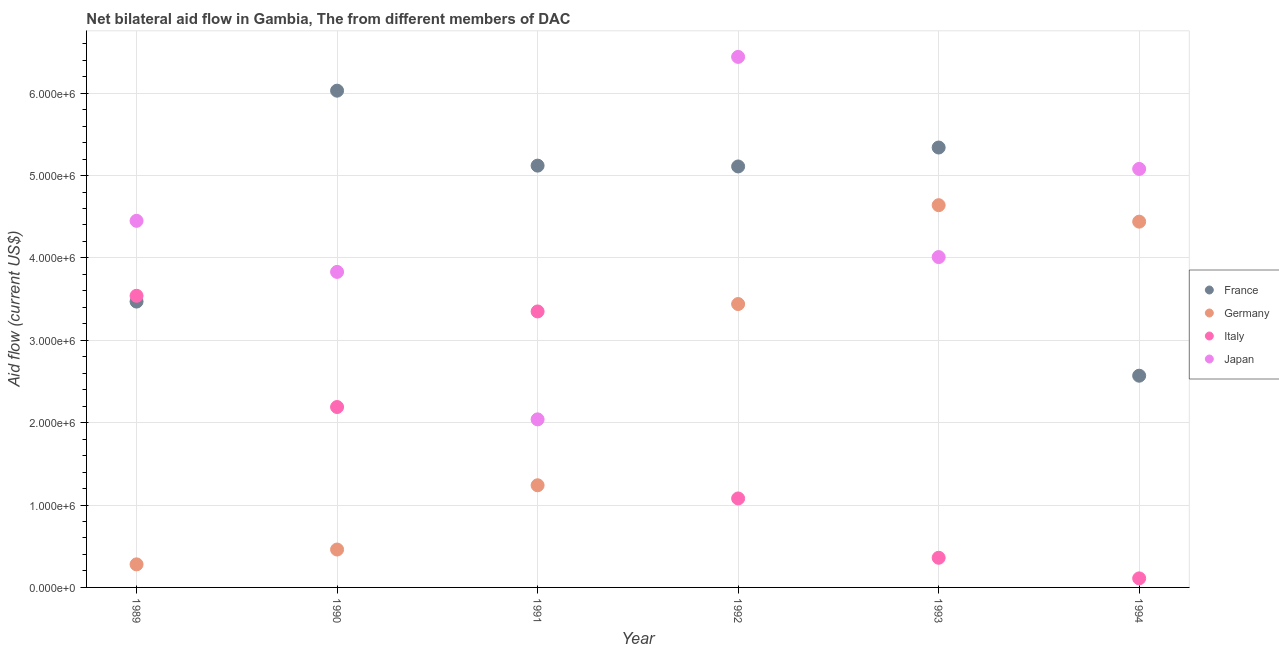Is the number of dotlines equal to the number of legend labels?
Ensure brevity in your answer.  Yes. What is the amount of aid given by italy in 1989?
Make the answer very short. 3.54e+06. Across all years, what is the maximum amount of aid given by france?
Ensure brevity in your answer.  6.03e+06. Across all years, what is the minimum amount of aid given by france?
Offer a terse response. 2.57e+06. What is the total amount of aid given by germany in the graph?
Provide a short and direct response. 1.45e+07. What is the difference between the amount of aid given by italy in 1989 and that in 1993?
Give a very brief answer. 3.18e+06. What is the difference between the amount of aid given by france in 1989 and the amount of aid given by japan in 1994?
Provide a short and direct response. -1.61e+06. What is the average amount of aid given by japan per year?
Your answer should be compact. 4.31e+06. In the year 1989, what is the difference between the amount of aid given by italy and amount of aid given by japan?
Give a very brief answer. -9.10e+05. What is the ratio of the amount of aid given by japan in 1991 to that in 1994?
Your answer should be compact. 0.4. Is the amount of aid given by italy in 1989 less than that in 1994?
Ensure brevity in your answer.  No. Is the difference between the amount of aid given by france in 1990 and 1994 greater than the difference between the amount of aid given by japan in 1990 and 1994?
Your answer should be compact. Yes. What is the difference between the highest and the second highest amount of aid given by germany?
Give a very brief answer. 2.00e+05. What is the difference between the highest and the lowest amount of aid given by germany?
Give a very brief answer. 4.36e+06. Is the sum of the amount of aid given by france in 1990 and 1991 greater than the maximum amount of aid given by italy across all years?
Ensure brevity in your answer.  Yes. Is it the case that in every year, the sum of the amount of aid given by france and amount of aid given by italy is greater than the sum of amount of aid given by germany and amount of aid given by japan?
Keep it short and to the point. No. Is it the case that in every year, the sum of the amount of aid given by france and amount of aid given by germany is greater than the amount of aid given by italy?
Your answer should be very brief. Yes. Does the amount of aid given by japan monotonically increase over the years?
Keep it short and to the point. No. Is the amount of aid given by germany strictly less than the amount of aid given by japan over the years?
Your response must be concise. No. How many dotlines are there?
Your response must be concise. 4. Does the graph contain grids?
Offer a very short reply. Yes. Where does the legend appear in the graph?
Offer a very short reply. Center right. How many legend labels are there?
Your answer should be very brief. 4. What is the title of the graph?
Your response must be concise. Net bilateral aid flow in Gambia, The from different members of DAC. Does "Burnt food" appear as one of the legend labels in the graph?
Give a very brief answer. No. What is the Aid flow (current US$) in France in 1989?
Make the answer very short. 3.47e+06. What is the Aid flow (current US$) of Italy in 1989?
Provide a succinct answer. 3.54e+06. What is the Aid flow (current US$) of Japan in 1989?
Your answer should be very brief. 4.45e+06. What is the Aid flow (current US$) of France in 1990?
Give a very brief answer. 6.03e+06. What is the Aid flow (current US$) in Italy in 1990?
Your answer should be compact. 2.19e+06. What is the Aid flow (current US$) of Japan in 1990?
Make the answer very short. 3.83e+06. What is the Aid flow (current US$) of France in 1991?
Your answer should be compact. 5.12e+06. What is the Aid flow (current US$) of Germany in 1991?
Your answer should be compact. 1.24e+06. What is the Aid flow (current US$) of Italy in 1991?
Give a very brief answer. 3.35e+06. What is the Aid flow (current US$) of Japan in 1991?
Offer a terse response. 2.04e+06. What is the Aid flow (current US$) of France in 1992?
Make the answer very short. 5.11e+06. What is the Aid flow (current US$) in Germany in 1992?
Offer a very short reply. 3.44e+06. What is the Aid flow (current US$) in Italy in 1992?
Your response must be concise. 1.08e+06. What is the Aid flow (current US$) of Japan in 1992?
Keep it short and to the point. 6.44e+06. What is the Aid flow (current US$) of France in 1993?
Offer a very short reply. 5.34e+06. What is the Aid flow (current US$) of Germany in 1993?
Your response must be concise. 4.64e+06. What is the Aid flow (current US$) of Japan in 1993?
Provide a short and direct response. 4.01e+06. What is the Aid flow (current US$) of France in 1994?
Give a very brief answer. 2.57e+06. What is the Aid flow (current US$) in Germany in 1994?
Keep it short and to the point. 4.44e+06. What is the Aid flow (current US$) of Japan in 1994?
Make the answer very short. 5.08e+06. Across all years, what is the maximum Aid flow (current US$) of France?
Keep it short and to the point. 6.03e+06. Across all years, what is the maximum Aid flow (current US$) in Germany?
Your answer should be compact. 4.64e+06. Across all years, what is the maximum Aid flow (current US$) in Italy?
Offer a terse response. 3.54e+06. Across all years, what is the maximum Aid flow (current US$) in Japan?
Your answer should be compact. 6.44e+06. Across all years, what is the minimum Aid flow (current US$) in France?
Your answer should be very brief. 2.57e+06. Across all years, what is the minimum Aid flow (current US$) in Japan?
Keep it short and to the point. 2.04e+06. What is the total Aid flow (current US$) of France in the graph?
Ensure brevity in your answer.  2.76e+07. What is the total Aid flow (current US$) in Germany in the graph?
Provide a succinct answer. 1.45e+07. What is the total Aid flow (current US$) of Italy in the graph?
Offer a terse response. 1.06e+07. What is the total Aid flow (current US$) of Japan in the graph?
Offer a terse response. 2.58e+07. What is the difference between the Aid flow (current US$) of France in 1989 and that in 1990?
Your response must be concise. -2.56e+06. What is the difference between the Aid flow (current US$) in Germany in 1989 and that in 1990?
Your answer should be very brief. -1.80e+05. What is the difference between the Aid flow (current US$) of Italy in 1989 and that in 1990?
Give a very brief answer. 1.35e+06. What is the difference between the Aid flow (current US$) of Japan in 1989 and that in 1990?
Offer a terse response. 6.20e+05. What is the difference between the Aid flow (current US$) of France in 1989 and that in 1991?
Offer a terse response. -1.65e+06. What is the difference between the Aid flow (current US$) in Germany in 1989 and that in 1991?
Give a very brief answer. -9.60e+05. What is the difference between the Aid flow (current US$) in Japan in 1989 and that in 1991?
Offer a very short reply. 2.41e+06. What is the difference between the Aid flow (current US$) in France in 1989 and that in 1992?
Give a very brief answer. -1.64e+06. What is the difference between the Aid flow (current US$) of Germany in 1989 and that in 1992?
Your answer should be compact. -3.16e+06. What is the difference between the Aid flow (current US$) in Italy in 1989 and that in 1992?
Make the answer very short. 2.46e+06. What is the difference between the Aid flow (current US$) of Japan in 1989 and that in 1992?
Your answer should be very brief. -1.99e+06. What is the difference between the Aid flow (current US$) of France in 1989 and that in 1993?
Provide a short and direct response. -1.87e+06. What is the difference between the Aid flow (current US$) in Germany in 1989 and that in 1993?
Your answer should be very brief. -4.36e+06. What is the difference between the Aid flow (current US$) of Italy in 1989 and that in 1993?
Provide a short and direct response. 3.18e+06. What is the difference between the Aid flow (current US$) in Germany in 1989 and that in 1994?
Provide a succinct answer. -4.16e+06. What is the difference between the Aid flow (current US$) of Italy in 1989 and that in 1994?
Keep it short and to the point. 3.43e+06. What is the difference between the Aid flow (current US$) in Japan in 1989 and that in 1994?
Your answer should be very brief. -6.30e+05. What is the difference between the Aid flow (current US$) in France in 1990 and that in 1991?
Your answer should be very brief. 9.10e+05. What is the difference between the Aid flow (current US$) in Germany in 1990 and that in 1991?
Offer a terse response. -7.80e+05. What is the difference between the Aid flow (current US$) in Italy in 1990 and that in 1991?
Offer a very short reply. -1.16e+06. What is the difference between the Aid flow (current US$) of Japan in 1990 and that in 1991?
Offer a very short reply. 1.79e+06. What is the difference between the Aid flow (current US$) in France in 1990 and that in 1992?
Provide a short and direct response. 9.20e+05. What is the difference between the Aid flow (current US$) of Germany in 1990 and that in 1992?
Your answer should be compact. -2.98e+06. What is the difference between the Aid flow (current US$) of Italy in 1990 and that in 1992?
Ensure brevity in your answer.  1.11e+06. What is the difference between the Aid flow (current US$) of Japan in 1990 and that in 1992?
Your answer should be very brief. -2.61e+06. What is the difference between the Aid flow (current US$) of France in 1990 and that in 1993?
Offer a terse response. 6.90e+05. What is the difference between the Aid flow (current US$) of Germany in 1990 and that in 1993?
Ensure brevity in your answer.  -4.18e+06. What is the difference between the Aid flow (current US$) of Italy in 1990 and that in 1993?
Keep it short and to the point. 1.83e+06. What is the difference between the Aid flow (current US$) in France in 1990 and that in 1994?
Keep it short and to the point. 3.46e+06. What is the difference between the Aid flow (current US$) in Germany in 1990 and that in 1994?
Offer a terse response. -3.98e+06. What is the difference between the Aid flow (current US$) in Italy in 1990 and that in 1994?
Give a very brief answer. 2.08e+06. What is the difference between the Aid flow (current US$) of Japan in 1990 and that in 1994?
Give a very brief answer. -1.25e+06. What is the difference between the Aid flow (current US$) of Germany in 1991 and that in 1992?
Ensure brevity in your answer.  -2.20e+06. What is the difference between the Aid flow (current US$) in Italy in 1991 and that in 1992?
Your response must be concise. 2.27e+06. What is the difference between the Aid flow (current US$) in Japan in 1991 and that in 1992?
Give a very brief answer. -4.40e+06. What is the difference between the Aid flow (current US$) in Germany in 1991 and that in 1993?
Offer a very short reply. -3.40e+06. What is the difference between the Aid flow (current US$) in Italy in 1991 and that in 1993?
Your response must be concise. 2.99e+06. What is the difference between the Aid flow (current US$) in Japan in 1991 and that in 1993?
Offer a terse response. -1.97e+06. What is the difference between the Aid flow (current US$) of France in 1991 and that in 1994?
Offer a very short reply. 2.55e+06. What is the difference between the Aid flow (current US$) in Germany in 1991 and that in 1994?
Provide a succinct answer. -3.20e+06. What is the difference between the Aid flow (current US$) of Italy in 1991 and that in 1994?
Provide a short and direct response. 3.24e+06. What is the difference between the Aid flow (current US$) of Japan in 1991 and that in 1994?
Offer a very short reply. -3.04e+06. What is the difference between the Aid flow (current US$) of France in 1992 and that in 1993?
Your answer should be compact. -2.30e+05. What is the difference between the Aid flow (current US$) in Germany in 1992 and that in 1993?
Offer a terse response. -1.20e+06. What is the difference between the Aid flow (current US$) in Italy in 1992 and that in 1993?
Give a very brief answer. 7.20e+05. What is the difference between the Aid flow (current US$) in Japan in 1992 and that in 1993?
Your response must be concise. 2.43e+06. What is the difference between the Aid flow (current US$) of France in 1992 and that in 1994?
Give a very brief answer. 2.54e+06. What is the difference between the Aid flow (current US$) of Germany in 1992 and that in 1994?
Your answer should be compact. -1.00e+06. What is the difference between the Aid flow (current US$) of Italy in 1992 and that in 1994?
Give a very brief answer. 9.70e+05. What is the difference between the Aid flow (current US$) in Japan in 1992 and that in 1994?
Provide a short and direct response. 1.36e+06. What is the difference between the Aid flow (current US$) of France in 1993 and that in 1994?
Your response must be concise. 2.77e+06. What is the difference between the Aid flow (current US$) of Japan in 1993 and that in 1994?
Offer a very short reply. -1.07e+06. What is the difference between the Aid flow (current US$) of France in 1989 and the Aid flow (current US$) of Germany in 1990?
Your response must be concise. 3.01e+06. What is the difference between the Aid flow (current US$) of France in 1989 and the Aid flow (current US$) of Italy in 1990?
Give a very brief answer. 1.28e+06. What is the difference between the Aid flow (current US$) in France in 1989 and the Aid flow (current US$) in Japan in 1990?
Your answer should be very brief. -3.60e+05. What is the difference between the Aid flow (current US$) in Germany in 1989 and the Aid flow (current US$) in Italy in 1990?
Your response must be concise. -1.91e+06. What is the difference between the Aid flow (current US$) in Germany in 1989 and the Aid flow (current US$) in Japan in 1990?
Make the answer very short. -3.55e+06. What is the difference between the Aid flow (current US$) of France in 1989 and the Aid flow (current US$) of Germany in 1991?
Give a very brief answer. 2.23e+06. What is the difference between the Aid flow (current US$) of France in 1989 and the Aid flow (current US$) of Italy in 1991?
Make the answer very short. 1.20e+05. What is the difference between the Aid flow (current US$) in France in 1989 and the Aid flow (current US$) in Japan in 1991?
Make the answer very short. 1.43e+06. What is the difference between the Aid flow (current US$) in Germany in 1989 and the Aid flow (current US$) in Italy in 1991?
Make the answer very short. -3.07e+06. What is the difference between the Aid flow (current US$) of Germany in 1989 and the Aid flow (current US$) of Japan in 1991?
Give a very brief answer. -1.76e+06. What is the difference between the Aid flow (current US$) of Italy in 1989 and the Aid flow (current US$) of Japan in 1991?
Provide a short and direct response. 1.50e+06. What is the difference between the Aid flow (current US$) in France in 1989 and the Aid flow (current US$) in Italy in 1992?
Keep it short and to the point. 2.39e+06. What is the difference between the Aid flow (current US$) in France in 1989 and the Aid flow (current US$) in Japan in 1992?
Provide a succinct answer. -2.97e+06. What is the difference between the Aid flow (current US$) in Germany in 1989 and the Aid flow (current US$) in Italy in 1992?
Your response must be concise. -8.00e+05. What is the difference between the Aid flow (current US$) in Germany in 1989 and the Aid flow (current US$) in Japan in 1992?
Your answer should be very brief. -6.16e+06. What is the difference between the Aid flow (current US$) of Italy in 1989 and the Aid flow (current US$) of Japan in 1992?
Keep it short and to the point. -2.90e+06. What is the difference between the Aid flow (current US$) of France in 1989 and the Aid flow (current US$) of Germany in 1993?
Offer a very short reply. -1.17e+06. What is the difference between the Aid flow (current US$) in France in 1989 and the Aid flow (current US$) in Italy in 1993?
Make the answer very short. 3.11e+06. What is the difference between the Aid flow (current US$) in France in 1989 and the Aid flow (current US$) in Japan in 1993?
Offer a terse response. -5.40e+05. What is the difference between the Aid flow (current US$) of Germany in 1989 and the Aid flow (current US$) of Italy in 1993?
Provide a succinct answer. -8.00e+04. What is the difference between the Aid flow (current US$) in Germany in 1989 and the Aid flow (current US$) in Japan in 1993?
Your answer should be very brief. -3.73e+06. What is the difference between the Aid flow (current US$) of Italy in 1989 and the Aid flow (current US$) of Japan in 1993?
Keep it short and to the point. -4.70e+05. What is the difference between the Aid flow (current US$) of France in 1989 and the Aid flow (current US$) of Germany in 1994?
Ensure brevity in your answer.  -9.70e+05. What is the difference between the Aid flow (current US$) in France in 1989 and the Aid flow (current US$) in Italy in 1994?
Provide a succinct answer. 3.36e+06. What is the difference between the Aid flow (current US$) in France in 1989 and the Aid flow (current US$) in Japan in 1994?
Ensure brevity in your answer.  -1.61e+06. What is the difference between the Aid flow (current US$) of Germany in 1989 and the Aid flow (current US$) of Japan in 1994?
Your response must be concise. -4.80e+06. What is the difference between the Aid flow (current US$) in Italy in 1989 and the Aid flow (current US$) in Japan in 1994?
Offer a terse response. -1.54e+06. What is the difference between the Aid flow (current US$) in France in 1990 and the Aid flow (current US$) in Germany in 1991?
Keep it short and to the point. 4.79e+06. What is the difference between the Aid flow (current US$) of France in 1990 and the Aid flow (current US$) of Italy in 1991?
Your response must be concise. 2.68e+06. What is the difference between the Aid flow (current US$) in France in 1990 and the Aid flow (current US$) in Japan in 1991?
Your response must be concise. 3.99e+06. What is the difference between the Aid flow (current US$) in Germany in 1990 and the Aid flow (current US$) in Italy in 1991?
Your response must be concise. -2.89e+06. What is the difference between the Aid flow (current US$) of Germany in 1990 and the Aid flow (current US$) of Japan in 1991?
Provide a short and direct response. -1.58e+06. What is the difference between the Aid flow (current US$) of France in 1990 and the Aid flow (current US$) of Germany in 1992?
Keep it short and to the point. 2.59e+06. What is the difference between the Aid flow (current US$) of France in 1990 and the Aid flow (current US$) of Italy in 1992?
Ensure brevity in your answer.  4.95e+06. What is the difference between the Aid flow (current US$) in France in 1990 and the Aid flow (current US$) in Japan in 1992?
Offer a terse response. -4.10e+05. What is the difference between the Aid flow (current US$) of Germany in 1990 and the Aid flow (current US$) of Italy in 1992?
Ensure brevity in your answer.  -6.20e+05. What is the difference between the Aid flow (current US$) of Germany in 1990 and the Aid flow (current US$) of Japan in 1992?
Provide a succinct answer. -5.98e+06. What is the difference between the Aid flow (current US$) of Italy in 1990 and the Aid flow (current US$) of Japan in 1992?
Ensure brevity in your answer.  -4.25e+06. What is the difference between the Aid flow (current US$) in France in 1990 and the Aid flow (current US$) in Germany in 1993?
Your response must be concise. 1.39e+06. What is the difference between the Aid flow (current US$) of France in 1990 and the Aid flow (current US$) of Italy in 1993?
Ensure brevity in your answer.  5.67e+06. What is the difference between the Aid flow (current US$) in France in 1990 and the Aid flow (current US$) in Japan in 1993?
Your answer should be compact. 2.02e+06. What is the difference between the Aid flow (current US$) of Germany in 1990 and the Aid flow (current US$) of Japan in 1993?
Your response must be concise. -3.55e+06. What is the difference between the Aid flow (current US$) in Italy in 1990 and the Aid flow (current US$) in Japan in 1993?
Your answer should be compact. -1.82e+06. What is the difference between the Aid flow (current US$) of France in 1990 and the Aid flow (current US$) of Germany in 1994?
Keep it short and to the point. 1.59e+06. What is the difference between the Aid flow (current US$) in France in 1990 and the Aid flow (current US$) in Italy in 1994?
Provide a succinct answer. 5.92e+06. What is the difference between the Aid flow (current US$) in France in 1990 and the Aid flow (current US$) in Japan in 1994?
Offer a very short reply. 9.50e+05. What is the difference between the Aid flow (current US$) of Germany in 1990 and the Aid flow (current US$) of Italy in 1994?
Offer a very short reply. 3.50e+05. What is the difference between the Aid flow (current US$) in Germany in 1990 and the Aid flow (current US$) in Japan in 1994?
Your response must be concise. -4.62e+06. What is the difference between the Aid flow (current US$) of Italy in 1990 and the Aid flow (current US$) of Japan in 1994?
Ensure brevity in your answer.  -2.89e+06. What is the difference between the Aid flow (current US$) of France in 1991 and the Aid flow (current US$) of Germany in 1992?
Your answer should be compact. 1.68e+06. What is the difference between the Aid flow (current US$) of France in 1991 and the Aid flow (current US$) of Italy in 1992?
Ensure brevity in your answer.  4.04e+06. What is the difference between the Aid flow (current US$) of France in 1991 and the Aid flow (current US$) of Japan in 1992?
Provide a short and direct response. -1.32e+06. What is the difference between the Aid flow (current US$) in Germany in 1991 and the Aid flow (current US$) in Italy in 1992?
Provide a short and direct response. 1.60e+05. What is the difference between the Aid flow (current US$) of Germany in 1991 and the Aid flow (current US$) of Japan in 1992?
Ensure brevity in your answer.  -5.20e+06. What is the difference between the Aid flow (current US$) in Italy in 1991 and the Aid flow (current US$) in Japan in 1992?
Provide a short and direct response. -3.09e+06. What is the difference between the Aid flow (current US$) of France in 1991 and the Aid flow (current US$) of Germany in 1993?
Your answer should be very brief. 4.80e+05. What is the difference between the Aid flow (current US$) of France in 1991 and the Aid flow (current US$) of Italy in 1993?
Your answer should be very brief. 4.76e+06. What is the difference between the Aid flow (current US$) in France in 1991 and the Aid flow (current US$) in Japan in 1993?
Ensure brevity in your answer.  1.11e+06. What is the difference between the Aid flow (current US$) in Germany in 1991 and the Aid flow (current US$) in Italy in 1993?
Ensure brevity in your answer.  8.80e+05. What is the difference between the Aid flow (current US$) in Germany in 1991 and the Aid flow (current US$) in Japan in 1993?
Offer a very short reply. -2.77e+06. What is the difference between the Aid flow (current US$) of Italy in 1991 and the Aid flow (current US$) of Japan in 1993?
Keep it short and to the point. -6.60e+05. What is the difference between the Aid flow (current US$) of France in 1991 and the Aid flow (current US$) of Germany in 1994?
Your answer should be very brief. 6.80e+05. What is the difference between the Aid flow (current US$) of France in 1991 and the Aid flow (current US$) of Italy in 1994?
Provide a short and direct response. 5.01e+06. What is the difference between the Aid flow (current US$) in Germany in 1991 and the Aid flow (current US$) in Italy in 1994?
Offer a very short reply. 1.13e+06. What is the difference between the Aid flow (current US$) in Germany in 1991 and the Aid flow (current US$) in Japan in 1994?
Your answer should be very brief. -3.84e+06. What is the difference between the Aid flow (current US$) of Italy in 1991 and the Aid flow (current US$) of Japan in 1994?
Your answer should be very brief. -1.73e+06. What is the difference between the Aid flow (current US$) of France in 1992 and the Aid flow (current US$) of Germany in 1993?
Make the answer very short. 4.70e+05. What is the difference between the Aid flow (current US$) in France in 1992 and the Aid flow (current US$) in Italy in 1993?
Give a very brief answer. 4.75e+06. What is the difference between the Aid flow (current US$) in France in 1992 and the Aid flow (current US$) in Japan in 1993?
Your answer should be compact. 1.10e+06. What is the difference between the Aid flow (current US$) in Germany in 1992 and the Aid flow (current US$) in Italy in 1993?
Make the answer very short. 3.08e+06. What is the difference between the Aid flow (current US$) in Germany in 1992 and the Aid flow (current US$) in Japan in 1993?
Your answer should be very brief. -5.70e+05. What is the difference between the Aid flow (current US$) of Italy in 1992 and the Aid flow (current US$) of Japan in 1993?
Keep it short and to the point. -2.93e+06. What is the difference between the Aid flow (current US$) in France in 1992 and the Aid flow (current US$) in Germany in 1994?
Your response must be concise. 6.70e+05. What is the difference between the Aid flow (current US$) of France in 1992 and the Aid flow (current US$) of Japan in 1994?
Provide a succinct answer. 3.00e+04. What is the difference between the Aid flow (current US$) of Germany in 1992 and the Aid flow (current US$) of Italy in 1994?
Offer a very short reply. 3.33e+06. What is the difference between the Aid flow (current US$) of Germany in 1992 and the Aid flow (current US$) of Japan in 1994?
Make the answer very short. -1.64e+06. What is the difference between the Aid flow (current US$) in Italy in 1992 and the Aid flow (current US$) in Japan in 1994?
Make the answer very short. -4.00e+06. What is the difference between the Aid flow (current US$) in France in 1993 and the Aid flow (current US$) in Germany in 1994?
Give a very brief answer. 9.00e+05. What is the difference between the Aid flow (current US$) in France in 1993 and the Aid flow (current US$) in Italy in 1994?
Your response must be concise. 5.23e+06. What is the difference between the Aid flow (current US$) in Germany in 1993 and the Aid flow (current US$) in Italy in 1994?
Your response must be concise. 4.53e+06. What is the difference between the Aid flow (current US$) in Germany in 1993 and the Aid flow (current US$) in Japan in 1994?
Offer a very short reply. -4.40e+05. What is the difference between the Aid flow (current US$) in Italy in 1993 and the Aid flow (current US$) in Japan in 1994?
Your answer should be compact. -4.72e+06. What is the average Aid flow (current US$) in France per year?
Your answer should be very brief. 4.61e+06. What is the average Aid flow (current US$) in Germany per year?
Provide a succinct answer. 2.42e+06. What is the average Aid flow (current US$) of Italy per year?
Provide a succinct answer. 1.77e+06. What is the average Aid flow (current US$) of Japan per year?
Make the answer very short. 4.31e+06. In the year 1989, what is the difference between the Aid flow (current US$) in France and Aid flow (current US$) in Germany?
Your response must be concise. 3.19e+06. In the year 1989, what is the difference between the Aid flow (current US$) of France and Aid flow (current US$) of Japan?
Your answer should be compact. -9.80e+05. In the year 1989, what is the difference between the Aid flow (current US$) of Germany and Aid flow (current US$) of Italy?
Offer a terse response. -3.26e+06. In the year 1989, what is the difference between the Aid flow (current US$) in Germany and Aid flow (current US$) in Japan?
Offer a very short reply. -4.17e+06. In the year 1989, what is the difference between the Aid flow (current US$) in Italy and Aid flow (current US$) in Japan?
Give a very brief answer. -9.10e+05. In the year 1990, what is the difference between the Aid flow (current US$) in France and Aid flow (current US$) in Germany?
Keep it short and to the point. 5.57e+06. In the year 1990, what is the difference between the Aid flow (current US$) in France and Aid flow (current US$) in Italy?
Your answer should be compact. 3.84e+06. In the year 1990, what is the difference between the Aid flow (current US$) of France and Aid flow (current US$) of Japan?
Your answer should be compact. 2.20e+06. In the year 1990, what is the difference between the Aid flow (current US$) in Germany and Aid flow (current US$) in Italy?
Make the answer very short. -1.73e+06. In the year 1990, what is the difference between the Aid flow (current US$) in Germany and Aid flow (current US$) in Japan?
Give a very brief answer. -3.37e+06. In the year 1990, what is the difference between the Aid flow (current US$) of Italy and Aid flow (current US$) of Japan?
Offer a very short reply. -1.64e+06. In the year 1991, what is the difference between the Aid flow (current US$) of France and Aid flow (current US$) of Germany?
Keep it short and to the point. 3.88e+06. In the year 1991, what is the difference between the Aid flow (current US$) of France and Aid flow (current US$) of Italy?
Provide a short and direct response. 1.77e+06. In the year 1991, what is the difference between the Aid flow (current US$) of France and Aid flow (current US$) of Japan?
Keep it short and to the point. 3.08e+06. In the year 1991, what is the difference between the Aid flow (current US$) of Germany and Aid flow (current US$) of Italy?
Your answer should be very brief. -2.11e+06. In the year 1991, what is the difference between the Aid flow (current US$) in Germany and Aid flow (current US$) in Japan?
Offer a very short reply. -8.00e+05. In the year 1991, what is the difference between the Aid flow (current US$) in Italy and Aid flow (current US$) in Japan?
Make the answer very short. 1.31e+06. In the year 1992, what is the difference between the Aid flow (current US$) in France and Aid flow (current US$) in Germany?
Ensure brevity in your answer.  1.67e+06. In the year 1992, what is the difference between the Aid flow (current US$) in France and Aid flow (current US$) in Italy?
Offer a terse response. 4.03e+06. In the year 1992, what is the difference between the Aid flow (current US$) of France and Aid flow (current US$) of Japan?
Give a very brief answer. -1.33e+06. In the year 1992, what is the difference between the Aid flow (current US$) in Germany and Aid flow (current US$) in Italy?
Keep it short and to the point. 2.36e+06. In the year 1992, what is the difference between the Aid flow (current US$) of Germany and Aid flow (current US$) of Japan?
Ensure brevity in your answer.  -3.00e+06. In the year 1992, what is the difference between the Aid flow (current US$) in Italy and Aid flow (current US$) in Japan?
Ensure brevity in your answer.  -5.36e+06. In the year 1993, what is the difference between the Aid flow (current US$) in France and Aid flow (current US$) in Italy?
Your response must be concise. 4.98e+06. In the year 1993, what is the difference between the Aid flow (current US$) of France and Aid flow (current US$) of Japan?
Provide a short and direct response. 1.33e+06. In the year 1993, what is the difference between the Aid flow (current US$) of Germany and Aid flow (current US$) of Italy?
Make the answer very short. 4.28e+06. In the year 1993, what is the difference between the Aid flow (current US$) in Germany and Aid flow (current US$) in Japan?
Offer a terse response. 6.30e+05. In the year 1993, what is the difference between the Aid flow (current US$) in Italy and Aid flow (current US$) in Japan?
Keep it short and to the point. -3.65e+06. In the year 1994, what is the difference between the Aid flow (current US$) of France and Aid flow (current US$) of Germany?
Ensure brevity in your answer.  -1.87e+06. In the year 1994, what is the difference between the Aid flow (current US$) of France and Aid flow (current US$) of Italy?
Your answer should be very brief. 2.46e+06. In the year 1994, what is the difference between the Aid flow (current US$) of France and Aid flow (current US$) of Japan?
Provide a short and direct response. -2.51e+06. In the year 1994, what is the difference between the Aid flow (current US$) of Germany and Aid flow (current US$) of Italy?
Make the answer very short. 4.33e+06. In the year 1994, what is the difference between the Aid flow (current US$) of Germany and Aid flow (current US$) of Japan?
Provide a short and direct response. -6.40e+05. In the year 1994, what is the difference between the Aid flow (current US$) in Italy and Aid flow (current US$) in Japan?
Provide a short and direct response. -4.97e+06. What is the ratio of the Aid flow (current US$) of France in 1989 to that in 1990?
Offer a very short reply. 0.58. What is the ratio of the Aid flow (current US$) in Germany in 1989 to that in 1990?
Offer a terse response. 0.61. What is the ratio of the Aid flow (current US$) of Italy in 1989 to that in 1990?
Your answer should be compact. 1.62. What is the ratio of the Aid flow (current US$) in Japan in 1989 to that in 1990?
Your response must be concise. 1.16. What is the ratio of the Aid flow (current US$) in France in 1989 to that in 1991?
Keep it short and to the point. 0.68. What is the ratio of the Aid flow (current US$) of Germany in 1989 to that in 1991?
Make the answer very short. 0.23. What is the ratio of the Aid flow (current US$) of Italy in 1989 to that in 1991?
Keep it short and to the point. 1.06. What is the ratio of the Aid flow (current US$) in Japan in 1989 to that in 1991?
Your answer should be very brief. 2.18. What is the ratio of the Aid flow (current US$) in France in 1989 to that in 1992?
Give a very brief answer. 0.68. What is the ratio of the Aid flow (current US$) of Germany in 1989 to that in 1992?
Your response must be concise. 0.08. What is the ratio of the Aid flow (current US$) in Italy in 1989 to that in 1992?
Ensure brevity in your answer.  3.28. What is the ratio of the Aid flow (current US$) of Japan in 1989 to that in 1992?
Give a very brief answer. 0.69. What is the ratio of the Aid flow (current US$) of France in 1989 to that in 1993?
Offer a terse response. 0.65. What is the ratio of the Aid flow (current US$) in Germany in 1989 to that in 1993?
Offer a very short reply. 0.06. What is the ratio of the Aid flow (current US$) in Italy in 1989 to that in 1993?
Offer a very short reply. 9.83. What is the ratio of the Aid flow (current US$) in Japan in 1989 to that in 1993?
Your answer should be very brief. 1.11. What is the ratio of the Aid flow (current US$) in France in 1989 to that in 1994?
Your answer should be very brief. 1.35. What is the ratio of the Aid flow (current US$) of Germany in 1989 to that in 1994?
Your answer should be very brief. 0.06. What is the ratio of the Aid flow (current US$) of Italy in 1989 to that in 1994?
Make the answer very short. 32.18. What is the ratio of the Aid flow (current US$) in Japan in 1989 to that in 1994?
Offer a very short reply. 0.88. What is the ratio of the Aid flow (current US$) of France in 1990 to that in 1991?
Keep it short and to the point. 1.18. What is the ratio of the Aid flow (current US$) of Germany in 1990 to that in 1991?
Offer a terse response. 0.37. What is the ratio of the Aid flow (current US$) in Italy in 1990 to that in 1991?
Your answer should be very brief. 0.65. What is the ratio of the Aid flow (current US$) in Japan in 1990 to that in 1991?
Offer a terse response. 1.88. What is the ratio of the Aid flow (current US$) of France in 1990 to that in 1992?
Provide a succinct answer. 1.18. What is the ratio of the Aid flow (current US$) in Germany in 1990 to that in 1992?
Make the answer very short. 0.13. What is the ratio of the Aid flow (current US$) in Italy in 1990 to that in 1992?
Your answer should be very brief. 2.03. What is the ratio of the Aid flow (current US$) in Japan in 1990 to that in 1992?
Your answer should be compact. 0.59. What is the ratio of the Aid flow (current US$) of France in 1990 to that in 1993?
Give a very brief answer. 1.13. What is the ratio of the Aid flow (current US$) in Germany in 1990 to that in 1993?
Your answer should be compact. 0.1. What is the ratio of the Aid flow (current US$) in Italy in 1990 to that in 1993?
Provide a short and direct response. 6.08. What is the ratio of the Aid flow (current US$) in Japan in 1990 to that in 1993?
Offer a terse response. 0.96. What is the ratio of the Aid flow (current US$) in France in 1990 to that in 1994?
Make the answer very short. 2.35. What is the ratio of the Aid flow (current US$) of Germany in 1990 to that in 1994?
Give a very brief answer. 0.1. What is the ratio of the Aid flow (current US$) in Italy in 1990 to that in 1994?
Your answer should be very brief. 19.91. What is the ratio of the Aid flow (current US$) in Japan in 1990 to that in 1994?
Keep it short and to the point. 0.75. What is the ratio of the Aid flow (current US$) in Germany in 1991 to that in 1992?
Ensure brevity in your answer.  0.36. What is the ratio of the Aid flow (current US$) in Italy in 1991 to that in 1992?
Offer a terse response. 3.1. What is the ratio of the Aid flow (current US$) of Japan in 1991 to that in 1992?
Keep it short and to the point. 0.32. What is the ratio of the Aid flow (current US$) of France in 1991 to that in 1993?
Keep it short and to the point. 0.96. What is the ratio of the Aid flow (current US$) in Germany in 1991 to that in 1993?
Keep it short and to the point. 0.27. What is the ratio of the Aid flow (current US$) of Italy in 1991 to that in 1993?
Provide a succinct answer. 9.31. What is the ratio of the Aid flow (current US$) of Japan in 1991 to that in 1993?
Offer a very short reply. 0.51. What is the ratio of the Aid flow (current US$) in France in 1991 to that in 1994?
Give a very brief answer. 1.99. What is the ratio of the Aid flow (current US$) of Germany in 1991 to that in 1994?
Offer a very short reply. 0.28. What is the ratio of the Aid flow (current US$) in Italy in 1991 to that in 1994?
Offer a very short reply. 30.45. What is the ratio of the Aid flow (current US$) of Japan in 1991 to that in 1994?
Give a very brief answer. 0.4. What is the ratio of the Aid flow (current US$) of France in 1992 to that in 1993?
Provide a short and direct response. 0.96. What is the ratio of the Aid flow (current US$) in Germany in 1992 to that in 1993?
Ensure brevity in your answer.  0.74. What is the ratio of the Aid flow (current US$) of Japan in 1992 to that in 1993?
Offer a very short reply. 1.61. What is the ratio of the Aid flow (current US$) of France in 1992 to that in 1994?
Give a very brief answer. 1.99. What is the ratio of the Aid flow (current US$) in Germany in 1992 to that in 1994?
Keep it short and to the point. 0.77. What is the ratio of the Aid flow (current US$) of Italy in 1992 to that in 1994?
Ensure brevity in your answer.  9.82. What is the ratio of the Aid flow (current US$) in Japan in 1992 to that in 1994?
Your response must be concise. 1.27. What is the ratio of the Aid flow (current US$) of France in 1993 to that in 1994?
Provide a short and direct response. 2.08. What is the ratio of the Aid flow (current US$) of Germany in 1993 to that in 1994?
Give a very brief answer. 1.04. What is the ratio of the Aid flow (current US$) in Italy in 1993 to that in 1994?
Provide a succinct answer. 3.27. What is the ratio of the Aid flow (current US$) in Japan in 1993 to that in 1994?
Offer a terse response. 0.79. What is the difference between the highest and the second highest Aid flow (current US$) in France?
Your answer should be very brief. 6.90e+05. What is the difference between the highest and the second highest Aid flow (current US$) in Japan?
Provide a short and direct response. 1.36e+06. What is the difference between the highest and the lowest Aid flow (current US$) in France?
Offer a terse response. 3.46e+06. What is the difference between the highest and the lowest Aid flow (current US$) in Germany?
Ensure brevity in your answer.  4.36e+06. What is the difference between the highest and the lowest Aid flow (current US$) of Italy?
Provide a succinct answer. 3.43e+06. What is the difference between the highest and the lowest Aid flow (current US$) in Japan?
Offer a very short reply. 4.40e+06. 